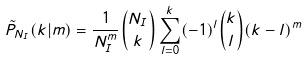Convert formula to latex. <formula><loc_0><loc_0><loc_500><loc_500>\tilde { P } _ { N _ { I } } ( k | m ) = \frac { 1 } { N _ { I } ^ { m } } { N _ { I } \choose k } \sum _ { l = 0 } ^ { k } ( - 1 ) ^ { l } { k \choose l } ( k - l ) ^ { m }</formula> 